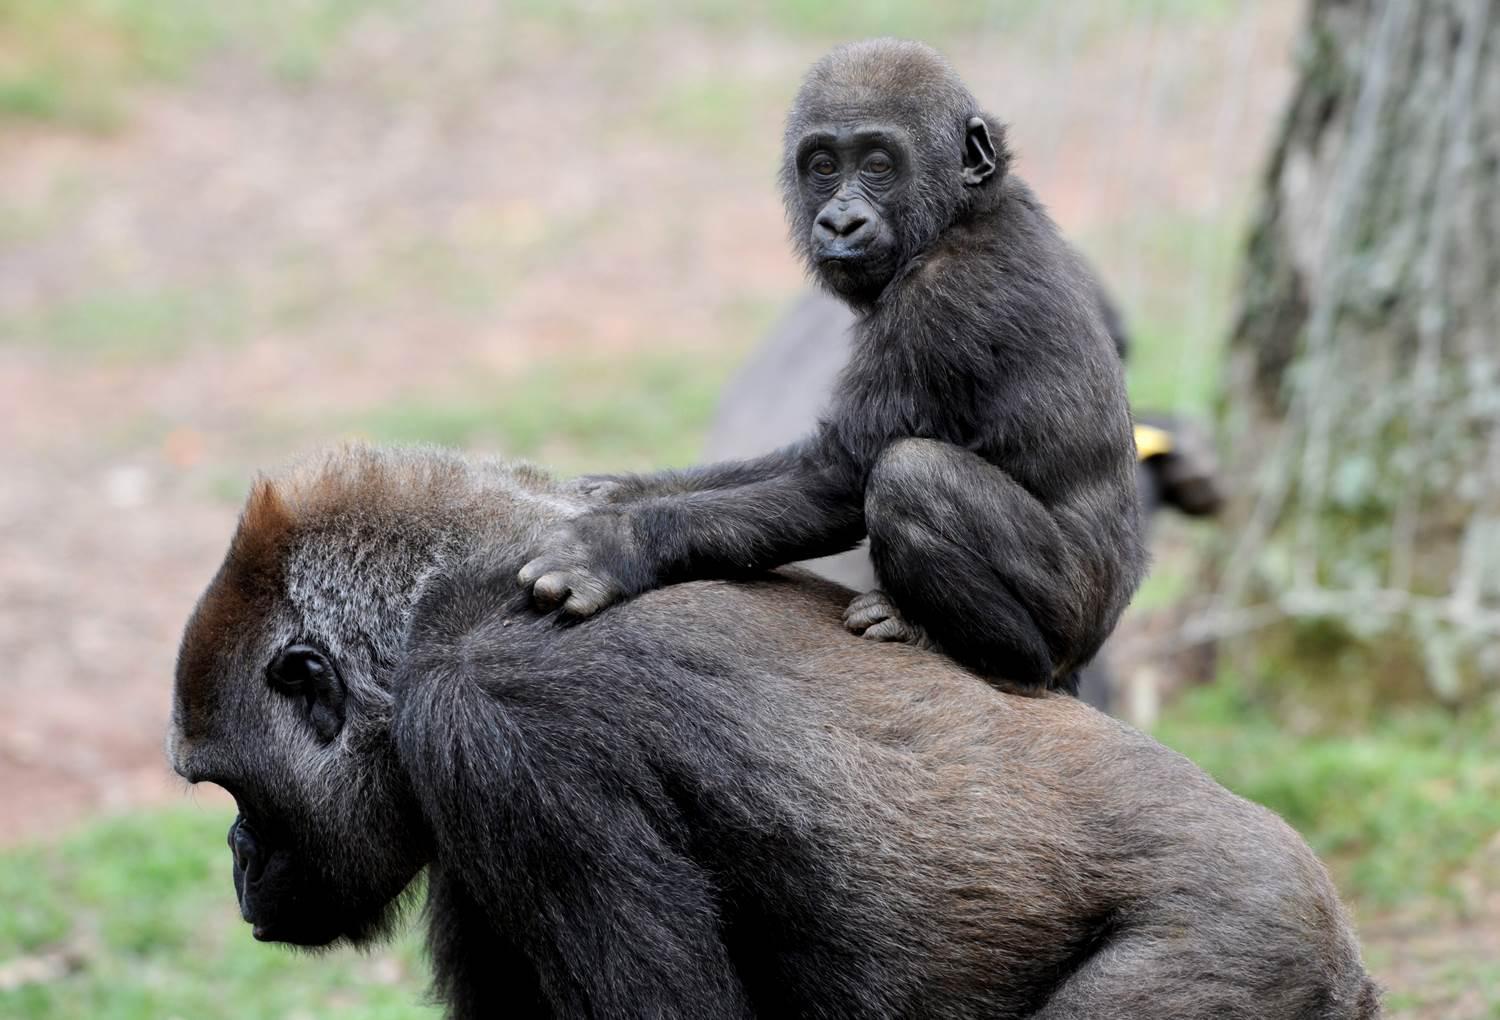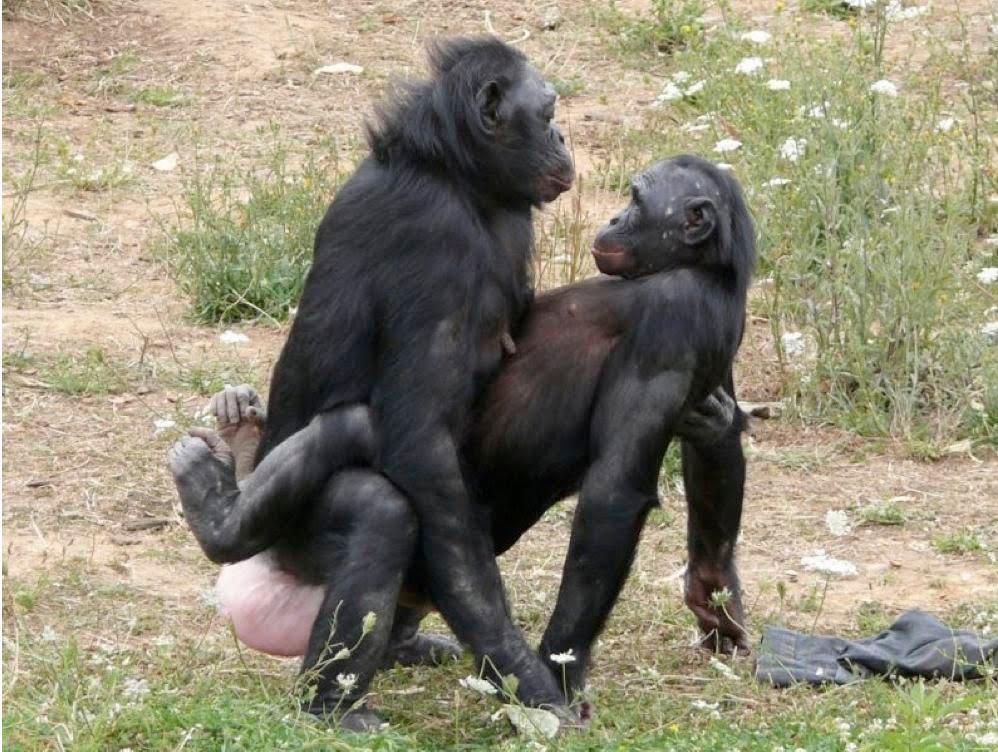The first image is the image on the left, the second image is the image on the right. Examine the images to the left and right. Is the description "A baby monkey is riding on an adult in the image on the right." accurate? Answer yes or no. No. 